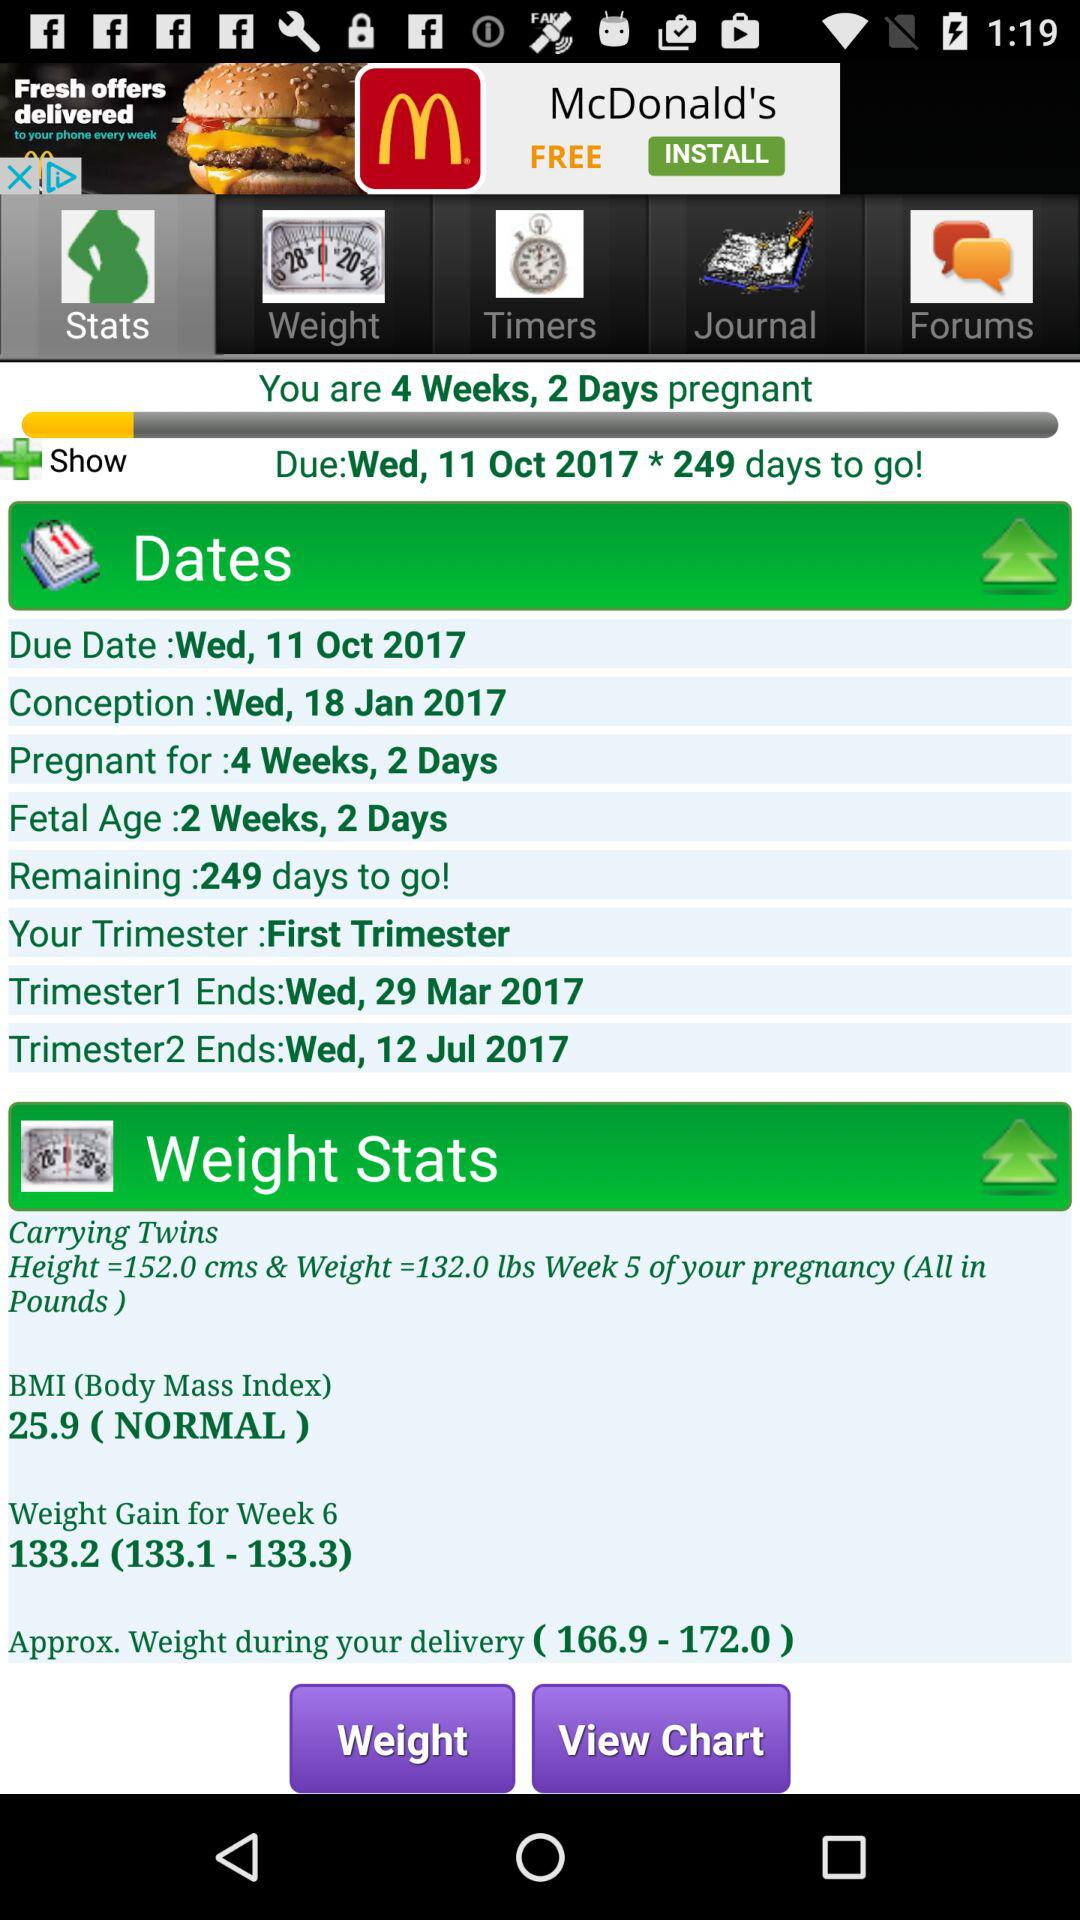Which tab is selected? The selected tab is "Stats". 